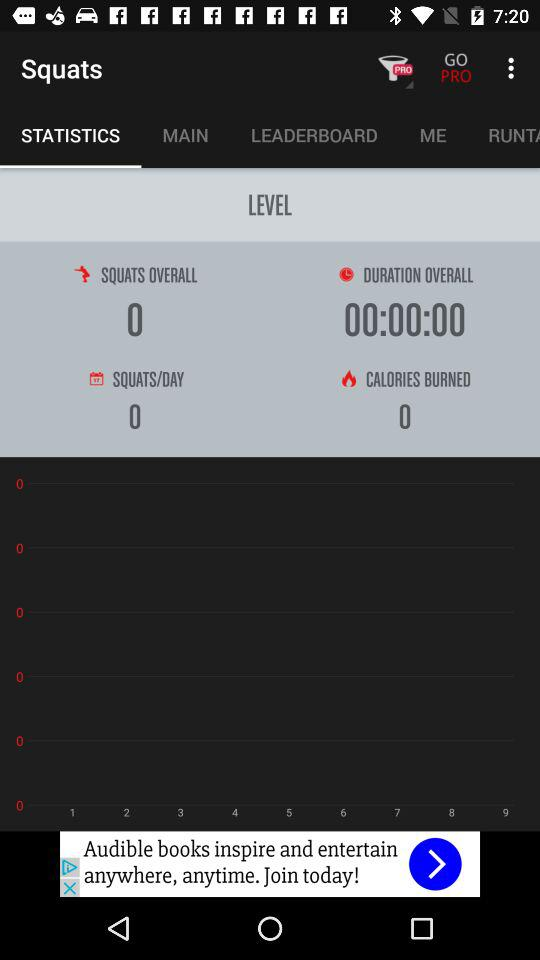Which tab is selected? The selected tab is "STATISTICS". 